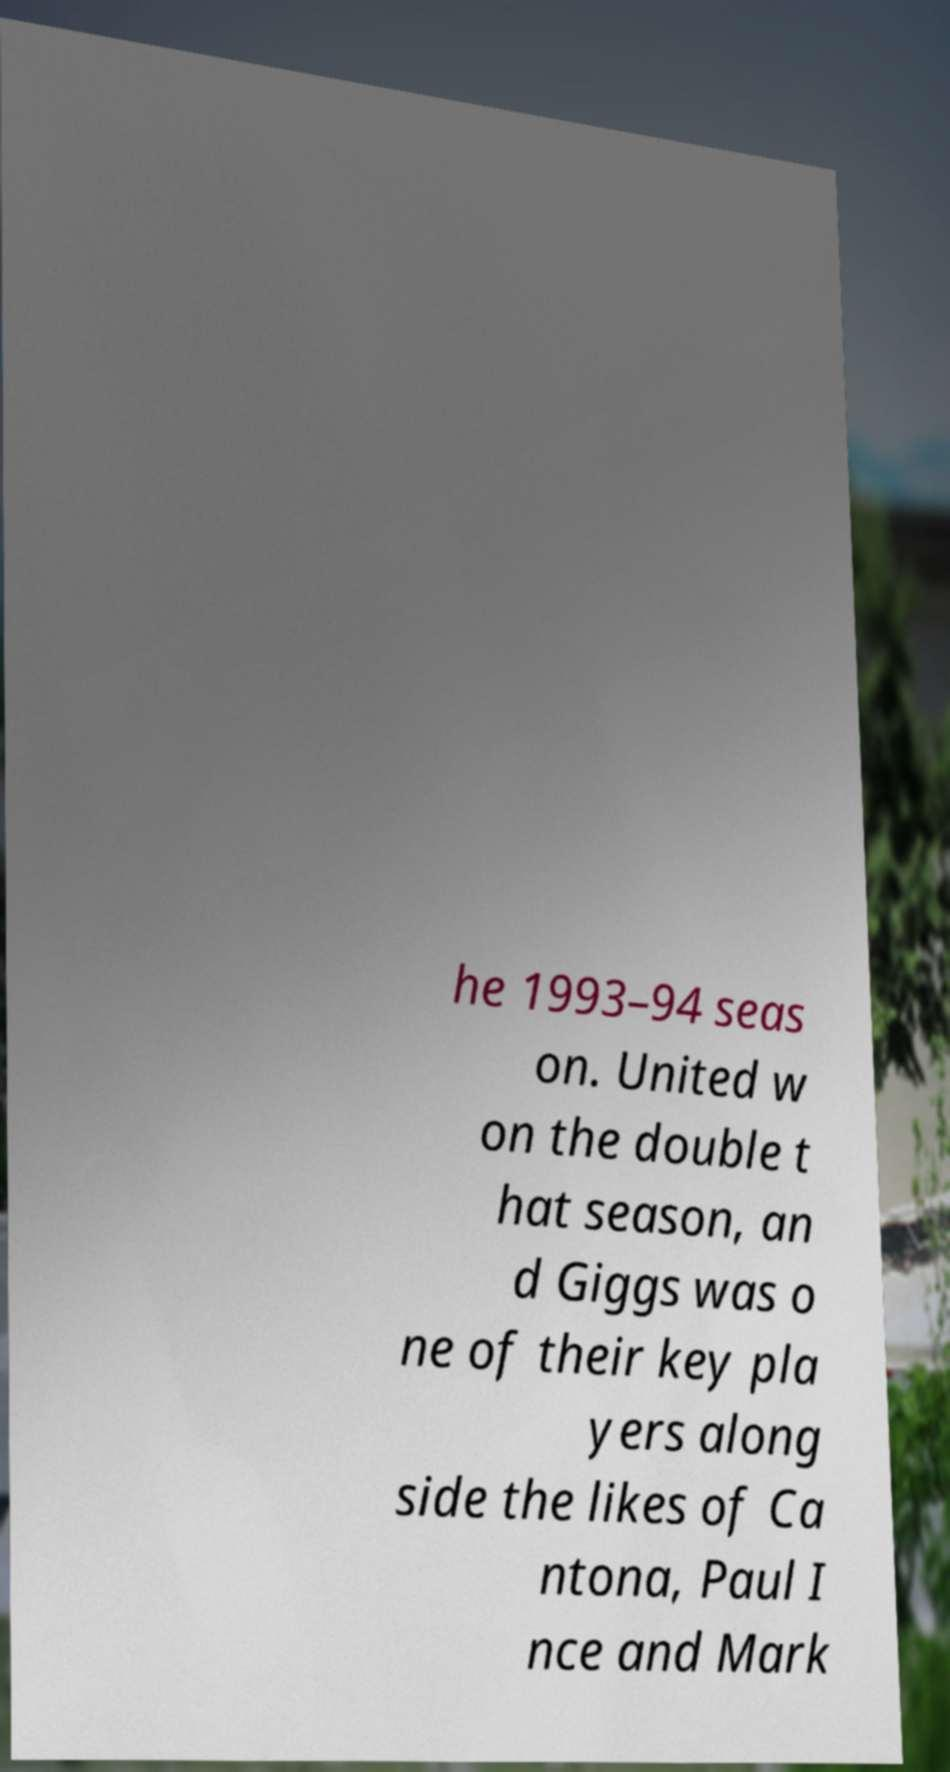What messages or text are displayed in this image? I need them in a readable, typed format. he 1993–94 seas on. United w on the double t hat season, an d Giggs was o ne of their key pla yers along side the likes of Ca ntona, Paul I nce and Mark 